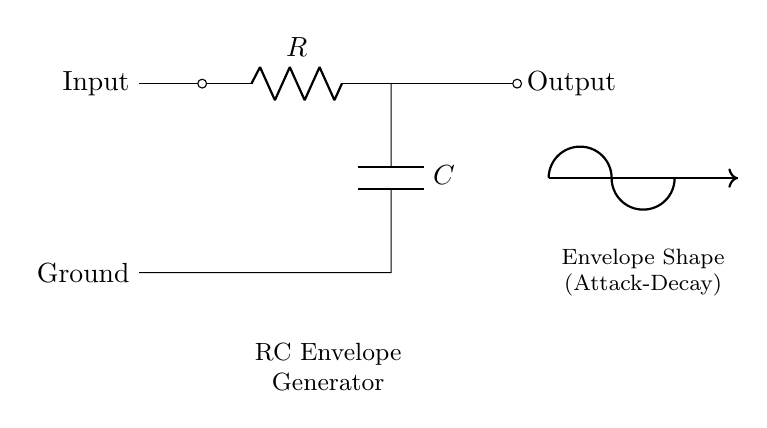What is the primary function of this circuit? The primary function of this RC envelope generator circuit is to shape audio signals, specifically to generate an envelope that can modify the dynamics of synthesizer sounds. This is achieved by controlling the attack and decay of signals, which affects how the sound evolves over time.
Answer: shape audio signals What components are present in the circuit? The circuit contains a resistor and a capacitor. The resistor (R) controls the charge and discharge rates, while the capacitor (C) stores energy and influences the envelope shape of the output signal.
Answer: resistor and capacitor What is the position of the output in relation to the input? The output is located downstream of the resistor, specifically at the right side of the circuit, indicating that the output signal is taken after the resistor but before reaching the capacitor. This configuration allows the envelope shape to be derived from the charge and discharge characteristics influenced by these components.
Answer: after the resistor What determines the envelope shape's attack and decay times? The envelope shape's attack and decay times are determined by the values of the resistor and capacitor. The time constants, calculated by the product of resistance (R) and capacitance (C), directly affect how quickly the capacitor charges and discharges. A larger resistor or capacitor results in a slower attack and decay.
Answer: resistor and capacitor values How does the envelope generator affect synthesizer sounds? The envelope generator modulates the amplitude and filter parameters of synthesizer sounds over time. By controlling how fast a sound reaches its peak (attack) and how it falls off (decay), musicians can create various expressive dynamics that fit different musical styles, enhancing the overall sound texture.
Answer: modulates amplitude and filter parameters 